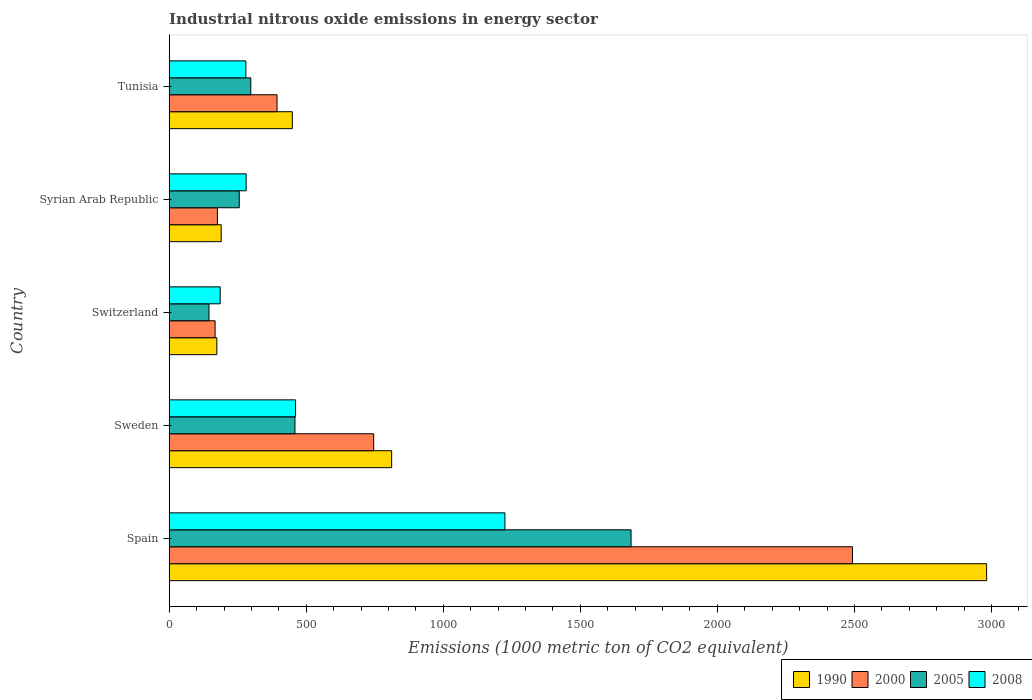How many different coloured bars are there?
Your answer should be compact. 4. Are the number of bars per tick equal to the number of legend labels?
Provide a succinct answer. Yes. Are the number of bars on each tick of the Y-axis equal?
Your answer should be very brief. Yes. How many bars are there on the 1st tick from the top?
Keep it short and to the point. 4. How many bars are there on the 2nd tick from the bottom?
Your answer should be very brief. 4. What is the label of the 2nd group of bars from the top?
Ensure brevity in your answer.  Syrian Arab Republic. In how many cases, is the number of bars for a given country not equal to the number of legend labels?
Offer a terse response. 0. What is the amount of industrial nitrous oxide emitted in 2005 in Syrian Arab Republic?
Your answer should be very brief. 255.6. Across all countries, what is the maximum amount of industrial nitrous oxide emitted in 2008?
Your response must be concise. 1224.9. Across all countries, what is the minimum amount of industrial nitrous oxide emitted in 2000?
Offer a terse response. 167.4. In which country was the amount of industrial nitrous oxide emitted in 1990 minimum?
Ensure brevity in your answer.  Switzerland. What is the total amount of industrial nitrous oxide emitted in 2008 in the graph?
Provide a succinct answer. 2432.5. What is the difference between the amount of industrial nitrous oxide emitted in 2008 in Syrian Arab Republic and that in Tunisia?
Provide a succinct answer. 0.9. What is the difference between the amount of industrial nitrous oxide emitted in 2008 in Syrian Arab Republic and the amount of industrial nitrous oxide emitted in 2000 in Spain?
Offer a terse response. -2212.3. What is the average amount of industrial nitrous oxide emitted in 2005 per country?
Offer a very short reply. 568.46. What is the difference between the amount of industrial nitrous oxide emitted in 1990 and amount of industrial nitrous oxide emitted in 2000 in Sweden?
Your answer should be very brief. 65.5. In how many countries, is the amount of industrial nitrous oxide emitted in 2005 greater than 2500 1000 metric ton?
Your answer should be very brief. 0. What is the ratio of the amount of industrial nitrous oxide emitted in 2005 in Switzerland to that in Tunisia?
Provide a short and direct response. 0.49. Is the difference between the amount of industrial nitrous oxide emitted in 1990 in Switzerland and Tunisia greater than the difference between the amount of industrial nitrous oxide emitted in 2000 in Switzerland and Tunisia?
Make the answer very short. No. What is the difference between the highest and the second highest amount of industrial nitrous oxide emitted in 2005?
Your response must be concise. 1226.3. What is the difference between the highest and the lowest amount of industrial nitrous oxide emitted in 2008?
Offer a terse response. 1038.9. Is it the case that in every country, the sum of the amount of industrial nitrous oxide emitted in 2000 and amount of industrial nitrous oxide emitted in 2008 is greater than the sum of amount of industrial nitrous oxide emitted in 2005 and amount of industrial nitrous oxide emitted in 1990?
Make the answer very short. No. What does the 4th bar from the top in Syrian Arab Republic represents?
Ensure brevity in your answer.  1990. What does the 2nd bar from the bottom in Tunisia represents?
Your response must be concise. 2000. Is it the case that in every country, the sum of the amount of industrial nitrous oxide emitted in 2008 and amount of industrial nitrous oxide emitted in 2000 is greater than the amount of industrial nitrous oxide emitted in 2005?
Make the answer very short. Yes. How many bars are there?
Your answer should be compact. 20. How many countries are there in the graph?
Your response must be concise. 5. What is the difference between two consecutive major ticks on the X-axis?
Your answer should be very brief. 500. Does the graph contain any zero values?
Provide a short and direct response. No. Where does the legend appear in the graph?
Provide a short and direct response. Bottom right. How many legend labels are there?
Make the answer very short. 4. What is the title of the graph?
Your response must be concise. Industrial nitrous oxide emissions in energy sector. Does "1971" appear as one of the legend labels in the graph?
Offer a very short reply. No. What is the label or title of the X-axis?
Your response must be concise. Emissions (1000 metric ton of CO2 equivalent). What is the Emissions (1000 metric ton of CO2 equivalent) in 1990 in Spain?
Offer a terse response. 2982.4. What is the Emissions (1000 metric ton of CO2 equivalent) of 2000 in Spain?
Provide a short and direct response. 2493. What is the Emissions (1000 metric ton of CO2 equivalent) in 2005 in Spain?
Keep it short and to the point. 1685.1. What is the Emissions (1000 metric ton of CO2 equivalent) in 2008 in Spain?
Keep it short and to the point. 1224.9. What is the Emissions (1000 metric ton of CO2 equivalent) of 1990 in Sweden?
Offer a very short reply. 811.6. What is the Emissions (1000 metric ton of CO2 equivalent) of 2000 in Sweden?
Give a very brief answer. 746.1. What is the Emissions (1000 metric ton of CO2 equivalent) in 2005 in Sweden?
Make the answer very short. 458.8. What is the Emissions (1000 metric ton of CO2 equivalent) in 2008 in Sweden?
Offer a very short reply. 461.1. What is the Emissions (1000 metric ton of CO2 equivalent) in 1990 in Switzerland?
Make the answer very short. 173.8. What is the Emissions (1000 metric ton of CO2 equivalent) in 2000 in Switzerland?
Offer a terse response. 167.4. What is the Emissions (1000 metric ton of CO2 equivalent) of 2005 in Switzerland?
Offer a very short reply. 145.1. What is the Emissions (1000 metric ton of CO2 equivalent) of 2008 in Switzerland?
Provide a short and direct response. 186. What is the Emissions (1000 metric ton of CO2 equivalent) of 1990 in Syrian Arab Republic?
Your answer should be very brief. 189.7. What is the Emissions (1000 metric ton of CO2 equivalent) in 2000 in Syrian Arab Republic?
Offer a terse response. 175.8. What is the Emissions (1000 metric ton of CO2 equivalent) in 2005 in Syrian Arab Republic?
Provide a succinct answer. 255.6. What is the Emissions (1000 metric ton of CO2 equivalent) of 2008 in Syrian Arab Republic?
Your answer should be compact. 280.7. What is the Emissions (1000 metric ton of CO2 equivalent) of 1990 in Tunisia?
Offer a very short reply. 449.2. What is the Emissions (1000 metric ton of CO2 equivalent) of 2000 in Tunisia?
Offer a very short reply. 393.4. What is the Emissions (1000 metric ton of CO2 equivalent) in 2005 in Tunisia?
Ensure brevity in your answer.  297.7. What is the Emissions (1000 metric ton of CO2 equivalent) in 2008 in Tunisia?
Make the answer very short. 279.8. Across all countries, what is the maximum Emissions (1000 metric ton of CO2 equivalent) in 1990?
Your answer should be compact. 2982.4. Across all countries, what is the maximum Emissions (1000 metric ton of CO2 equivalent) in 2000?
Ensure brevity in your answer.  2493. Across all countries, what is the maximum Emissions (1000 metric ton of CO2 equivalent) of 2005?
Your response must be concise. 1685.1. Across all countries, what is the maximum Emissions (1000 metric ton of CO2 equivalent) of 2008?
Provide a short and direct response. 1224.9. Across all countries, what is the minimum Emissions (1000 metric ton of CO2 equivalent) in 1990?
Provide a succinct answer. 173.8. Across all countries, what is the minimum Emissions (1000 metric ton of CO2 equivalent) in 2000?
Your answer should be very brief. 167.4. Across all countries, what is the minimum Emissions (1000 metric ton of CO2 equivalent) in 2005?
Provide a short and direct response. 145.1. Across all countries, what is the minimum Emissions (1000 metric ton of CO2 equivalent) of 2008?
Ensure brevity in your answer.  186. What is the total Emissions (1000 metric ton of CO2 equivalent) of 1990 in the graph?
Your answer should be compact. 4606.7. What is the total Emissions (1000 metric ton of CO2 equivalent) in 2000 in the graph?
Provide a short and direct response. 3975.7. What is the total Emissions (1000 metric ton of CO2 equivalent) of 2005 in the graph?
Offer a terse response. 2842.3. What is the total Emissions (1000 metric ton of CO2 equivalent) in 2008 in the graph?
Offer a very short reply. 2432.5. What is the difference between the Emissions (1000 metric ton of CO2 equivalent) of 1990 in Spain and that in Sweden?
Provide a short and direct response. 2170.8. What is the difference between the Emissions (1000 metric ton of CO2 equivalent) of 2000 in Spain and that in Sweden?
Make the answer very short. 1746.9. What is the difference between the Emissions (1000 metric ton of CO2 equivalent) in 2005 in Spain and that in Sweden?
Your answer should be compact. 1226.3. What is the difference between the Emissions (1000 metric ton of CO2 equivalent) in 2008 in Spain and that in Sweden?
Ensure brevity in your answer.  763.8. What is the difference between the Emissions (1000 metric ton of CO2 equivalent) of 1990 in Spain and that in Switzerland?
Your answer should be very brief. 2808.6. What is the difference between the Emissions (1000 metric ton of CO2 equivalent) of 2000 in Spain and that in Switzerland?
Offer a terse response. 2325.6. What is the difference between the Emissions (1000 metric ton of CO2 equivalent) of 2005 in Spain and that in Switzerland?
Provide a short and direct response. 1540. What is the difference between the Emissions (1000 metric ton of CO2 equivalent) in 2008 in Spain and that in Switzerland?
Your response must be concise. 1038.9. What is the difference between the Emissions (1000 metric ton of CO2 equivalent) of 1990 in Spain and that in Syrian Arab Republic?
Provide a succinct answer. 2792.7. What is the difference between the Emissions (1000 metric ton of CO2 equivalent) in 2000 in Spain and that in Syrian Arab Republic?
Make the answer very short. 2317.2. What is the difference between the Emissions (1000 metric ton of CO2 equivalent) in 2005 in Spain and that in Syrian Arab Republic?
Keep it short and to the point. 1429.5. What is the difference between the Emissions (1000 metric ton of CO2 equivalent) in 2008 in Spain and that in Syrian Arab Republic?
Your response must be concise. 944.2. What is the difference between the Emissions (1000 metric ton of CO2 equivalent) in 1990 in Spain and that in Tunisia?
Your answer should be compact. 2533.2. What is the difference between the Emissions (1000 metric ton of CO2 equivalent) in 2000 in Spain and that in Tunisia?
Provide a succinct answer. 2099.6. What is the difference between the Emissions (1000 metric ton of CO2 equivalent) of 2005 in Spain and that in Tunisia?
Keep it short and to the point. 1387.4. What is the difference between the Emissions (1000 metric ton of CO2 equivalent) in 2008 in Spain and that in Tunisia?
Your answer should be compact. 945.1. What is the difference between the Emissions (1000 metric ton of CO2 equivalent) in 1990 in Sweden and that in Switzerland?
Ensure brevity in your answer.  637.8. What is the difference between the Emissions (1000 metric ton of CO2 equivalent) in 2000 in Sweden and that in Switzerland?
Ensure brevity in your answer.  578.7. What is the difference between the Emissions (1000 metric ton of CO2 equivalent) of 2005 in Sweden and that in Switzerland?
Offer a very short reply. 313.7. What is the difference between the Emissions (1000 metric ton of CO2 equivalent) in 2008 in Sweden and that in Switzerland?
Provide a short and direct response. 275.1. What is the difference between the Emissions (1000 metric ton of CO2 equivalent) in 1990 in Sweden and that in Syrian Arab Republic?
Provide a succinct answer. 621.9. What is the difference between the Emissions (1000 metric ton of CO2 equivalent) in 2000 in Sweden and that in Syrian Arab Republic?
Ensure brevity in your answer.  570.3. What is the difference between the Emissions (1000 metric ton of CO2 equivalent) of 2005 in Sweden and that in Syrian Arab Republic?
Provide a short and direct response. 203.2. What is the difference between the Emissions (1000 metric ton of CO2 equivalent) in 2008 in Sweden and that in Syrian Arab Republic?
Offer a terse response. 180.4. What is the difference between the Emissions (1000 metric ton of CO2 equivalent) in 1990 in Sweden and that in Tunisia?
Your answer should be compact. 362.4. What is the difference between the Emissions (1000 metric ton of CO2 equivalent) in 2000 in Sweden and that in Tunisia?
Offer a very short reply. 352.7. What is the difference between the Emissions (1000 metric ton of CO2 equivalent) of 2005 in Sweden and that in Tunisia?
Offer a very short reply. 161.1. What is the difference between the Emissions (1000 metric ton of CO2 equivalent) of 2008 in Sweden and that in Tunisia?
Your answer should be very brief. 181.3. What is the difference between the Emissions (1000 metric ton of CO2 equivalent) in 1990 in Switzerland and that in Syrian Arab Republic?
Your response must be concise. -15.9. What is the difference between the Emissions (1000 metric ton of CO2 equivalent) in 2005 in Switzerland and that in Syrian Arab Republic?
Offer a terse response. -110.5. What is the difference between the Emissions (1000 metric ton of CO2 equivalent) in 2008 in Switzerland and that in Syrian Arab Republic?
Keep it short and to the point. -94.7. What is the difference between the Emissions (1000 metric ton of CO2 equivalent) in 1990 in Switzerland and that in Tunisia?
Your response must be concise. -275.4. What is the difference between the Emissions (1000 metric ton of CO2 equivalent) of 2000 in Switzerland and that in Tunisia?
Ensure brevity in your answer.  -226. What is the difference between the Emissions (1000 metric ton of CO2 equivalent) of 2005 in Switzerland and that in Tunisia?
Ensure brevity in your answer.  -152.6. What is the difference between the Emissions (1000 metric ton of CO2 equivalent) of 2008 in Switzerland and that in Tunisia?
Ensure brevity in your answer.  -93.8. What is the difference between the Emissions (1000 metric ton of CO2 equivalent) in 1990 in Syrian Arab Republic and that in Tunisia?
Provide a succinct answer. -259.5. What is the difference between the Emissions (1000 metric ton of CO2 equivalent) of 2000 in Syrian Arab Republic and that in Tunisia?
Provide a succinct answer. -217.6. What is the difference between the Emissions (1000 metric ton of CO2 equivalent) in 2005 in Syrian Arab Republic and that in Tunisia?
Give a very brief answer. -42.1. What is the difference between the Emissions (1000 metric ton of CO2 equivalent) in 2008 in Syrian Arab Republic and that in Tunisia?
Your answer should be compact. 0.9. What is the difference between the Emissions (1000 metric ton of CO2 equivalent) in 1990 in Spain and the Emissions (1000 metric ton of CO2 equivalent) in 2000 in Sweden?
Ensure brevity in your answer.  2236.3. What is the difference between the Emissions (1000 metric ton of CO2 equivalent) in 1990 in Spain and the Emissions (1000 metric ton of CO2 equivalent) in 2005 in Sweden?
Make the answer very short. 2523.6. What is the difference between the Emissions (1000 metric ton of CO2 equivalent) in 1990 in Spain and the Emissions (1000 metric ton of CO2 equivalent) in 2008 in Sweden?
Keep it short and to the point. 2521.3. What is the difference between the Emissions (1000 metric ton of CO2 equivalent) of 2000 in Spain and the Emissions (1000 metric ton of CO2 equivalent) of 2005 in Sweden?
Provide a short and direct response. 2034.2. What is the difference between the Emissions (1000 metric ton of CO2 equivalent) of 2000 in Spain and the Emissions (1000 metric ton of CO2 equivalent) of 2008 in Sweden?
Provide a short and direct response. 2031.9. What is the difference between the Emissions (1000 metric ton of CO2 equivalent) of 2005 in Spain and the Emissions (1000 metric ton of CO2 equivalent) of 2008 in Sweden?
Offer a very short reply. 1224. What is the difference between the Emissions (1000 metric ton of CO2 equivalent) of 1990 in Spain and the Emissions (1000 metric ton of CO2 equivalent) of 2000 in Switzerland?
Your answer should be compact. 2815. What is the difference between the Emissions (1000 metric ton of CO2 equivalent) of 1990 in Spain and the Emissions (1000 metric ton of CO2 equivalent) of 2005 in Switzerland?
Make the answer very short. 2837.3. What is the difference between the Emissions (1000 metric ton of CO2 equivalent) of 1990 in Spain and the Emissions (1000 metric ton of CO2 equivalent) of 2008 in Switzerland?
Your answer should be compact. 2796.4. What is the difference between the Emissions (1000 metric ton of CO2 equivalent) of 2000 in Spain and the Emissions (1000 metric ton of CO2 equivalent) of 2005 in Switzerland?
Provide a short and direct response. 2347.9. What is the difference between the Emissions (1000 metric ton of CO2 equivalent) of 2000 in Spain and the Emissions (1000 metric ton of CO2 equivalent) of 2008 in Switzerland?
Your answer should be very brief. 2307. What is the difference between the Emissions (1000 metric ton of CO2 equivalent) in 2005 in Spain and the Emissions (1000 metric ton of CO2 equivalent) in 2008 in Switzerland?
Your answer should be very brief. 1499.1. What is the difference between the Emissions (1000 metric ton of CO2 equivalent) of 1990 in Spain and the Emissions (1000 metric ton of CO2 equivalent) of 2000 in Syrian Arab Republic?
Your answer should be compact. 2806.6. What is the difference between the Emissions (1000 metric ton of CO2 equivalent) of 1990 in Spain and the Emissions (1000 metric ton of CO2 equivalent) of 2005 in Syrian Arab Republic?
Provide a succinct answer. 2726.8. What is the difference between the Emissions (1000 metric ton of CO2 equivalent) in 1990 in Spain and the Emissions (1000 metric ton of CO2 equivalent) in 2008 in Syrian Arab Republic?
Keep it short and to the point. 2701.7. What is the difference between the Emissions (1000 metric ton of CO2 equivalent) in 2000 in Spain and the Emissions (1000 metric ton of CO2 equivalent) in 2005 in Syrian Arab Republic?
Keep it short and to the point. 2237.4. What is the difference between the Emissions (1000 metric ton of CO2 equivalent) in 2000 in Spain and the Emissions (1000 metric ton of CO2 equivalent) in 2008 in Syrian Arab Republic?
Keep it short and to the point. 2212.3. What is the difference between the Emissions (1000 metric ton of CO2 equivalent) of 2005 in Spain and the Emissions (1000 metric ton of CO2 equivalent) of 2008 in Syrian Arab Republic?
Provide a succinct answer. 1404.4. What is the difference between the Emissions (1000 metric ton of CO2 equivalent) in 1990 in Spain and the Emissions (1000 metric ton of CO2 equivalent) in 2000 in Tunisia?
Keep it short and to the point. 2589. What is the difference between the Emissions (1000 metric ton of CO2 equivalent) of 1990 in Spain and the Emissions (1000 metric ton of CO2 equivalent) of 2005 in Tunisia?
Provide a short and direct response. 2684.7. What is the difference between the Emissions (1000 metric ton of CO2 equivalent) in 1990 in Spain and the Emissions (1000 metric ton of CO2 equivalent) in 2008 in Tunisia?
Your response must be concise. 2702.6. What is the difference between the Emissions (1000 metric ton of CO2 equivalent) in 2000 in Spain and the Emissions (1000 metric ton of CO2 equivalent) in 2005 in Tunisia?
Keep it short and to the point. 2195.3. What is the difference between the Emissions (1000 metric ton of CO2 equivalent) of 2000 in Spain and the Emissions (1000 metric ton of CO2 equivalent) of 2008 in Tunisia?
Your response must be concise. 2213.2. What is the difference between the Emissions (1000 metric ton of CO2 equivalent) in 2005 in Spain and the Emissions (1000 metric ton of CO2 equivalent) in 2008 in Tunisia?
Offer a terse response. 1405.3. What is the difference between the Emissions (1000 metric ton of CO2 equivalent) of 1990 in Sweden and the Emissions (1000 metric ton of CO2 equivalent) of 2000 in Switzerland?
Your answer should be very brief. 644.2. What is the difference between the Emissions (1000 metric ton of CO2 equivalent) of 1990 in Sweden and the Emissions (1000 metric ton of CO2 equivalent) of 2005 in Switzerland?
Your response must be concise. 666.5. What is the difference between the Emissions (1000 metric ton of CO2 equivalent) in 1990 in Sweden and the Emissions (1000 metric ton of CO2 equivalent) in 2008 in Switzerland?
Your answer should be compact. 625.6. What is the difference between the Emissions (1000 metric ton of CO2 equivalent) in 2000 in Sweden and the Emissions (1000 metric ton of CO2 equivalent) in 2005 in Switzerland?
Keep it short and to the point. 601. What is the difference between the Emissions (1000 metric ton of CO2 equivalent) of 2000 in Sweden and the Emissions (1000 metric ton of CO2 equivalent) of 2008 in Switzerland?
Ensure brevity in your answer.  560.1. What is the difference between the Emissions (1000 metric ton of CO2 equivalent) in 2005 in Sweden and the Emissions (1000 metric ton of CO2 equivalent) in 2008 in Switzerland?
Provide a short and direct response. 272.8. What is the difference between the Emissions (1000 metric ton of CO2 equivalent) in 1990 in Sweden and the Emissions (1000 metric ton of CO2 equivalent) in 2000 in Syrian Arab Republic?
Provide a succinct answer. 635.8. What is the difference between the Emissions (1000 metric ton of CO2 equivalent) of 1990 in Sweden and the Emissions (1000 metric ton of CO2 equivalent) of 2005 in Syrian Arab Republic?
Your answer should be very brief. 556. What is the difference between the Emissions (1000 metric ton of CO2 equivalent) of 1990 in Sweden and the Emissions (1000 metric ton of CO2 equivalent) of 2008 in Syrian Arab Republic?
Offer a very short reply. 530.9. What is the difference between the Emissions (1000 metric ton of CO2 equivalent) in 2000 in Sweden and the Emissions (1000 metric ton of CO2 equivalent) in 2005 in Syrian Arab Republic?
Your answer should be very brief. 490.5. What is the difference between the Emissions (1000 metric ton of CO2 equivalent) of 2000 in Sweden and the Emissions (1000 metric ton of CO2 equivalent) of 2008 in Syrian Arab Republic?
Give a very brief answer. 465.4. What is the difference between the Emissions (1000 metric ton of CO2 equivalent) of 2005 in Sweden and the Emissions (1000 metric ton of CO2 equivalent) of 2008 in Syrian Arab Republic?
Offer a very short reply. 178.1. What is the difference between the Emissions (1000 metric ton of CO2 equivalent) of 1990 in Sweden and the Emissions (1000 metric ton of CO2 equivalent) of 2000 in Tunisia?
Give a very brief answer. 418.2. What is the difference between the Emissions (1000 metric ton of CO2 equivalent) in 1990 in Sweden and the Emissions (1000 metric ton of CO2 equivalent) in 2005 in Tunisia?
Offer a very short reply. 513.9. What is the difference between the Emissions (1000 metric ton of CO2 equivalent) in 1990 in Sweden and the Emissions (1000 metric ton of CO2 equivalent) in 2008 in Tunisia?
Offer a very short reply. 531.8. What is the difference between the Emissions (1000 metric ton of CO2 equivalent) in 2000 in Sweden and the Emissions (1000 metric ton of CO2 equivalent) in 2005 in Tunisia?
Offer a terse response. 448.4. What is the difference between the Emissions (1000 metric ton of CO2 equivalent) of 2000 in Sweden and the Emissions (1000 metric ton of CO2 equivalent) of 2008 in Tunisia?
Your answer should be compact. 466.3. What is the difference between the Emissions (1000 metric ton of CO2 equivalent) in 2005 in Sweden and the Emissions (1000 metric ton of CO2 equivalent) in 2008 in Tunisia?
Keep it short and to the point. 179. What is the difference between the Emissions (1000 metric ton of CO2 equivalent) of 1990 in Switzerland and the Emissions (1000 metric ton of CO2 equivalent) of 2005 in Syrian Arab Republic?
Your answer should be compact. -81.8. What is the difference between the Emissions (1000 metric ton of CO2 equivalent) of 1990 in Switzerland and the Emissions (1000 metric ton of CO2 equivalent) of 2008 in Syrian Arab Republic?
Offer a terse response. -106.9. What is the difference between the Emissions (1000 metric ton of CO2 equivalent) of 2000 in Switzerland and the Emissions (1000 metric ton of CO2 equivalent) of 2005 in Syrian Arab Republic?
Keep it short and to the point. -88.2. What is the difference between the Emissions (1000 metric ton of CO2 equivalent) in 2000 in Switzerland and the Emissions (1000 metric ton of CO2 equivalent) in 2008 in Syrian Arab Republic?
Provide a short and direct response. -113.3. What is the difference between the Emissions (1000 metric ton of CO2 equivalent) of 2005 in Switzerland and the Emissions (1000 metric ton of CO2 equivalent) of 2008 in Syrian Arab Republic?
Give a very brief answer. -135.6. What is the difference between the Emissions (1000 metric ton of CO2 equivalent) of 1990 in Switzerland and the Emissions (1000 metric ton of CO2 equivalent) of 2000 in Tunisia?
Your answer should be very brief. -219.6. What is the difference between the Emissions (1000 metric ton of CO2 equivalent) in 1990 in Switzerland and the Emissions (1000 metric ton of CO2 equivalent) in 2005 in Tunisia?
Keep it short and to the point. -123.9. What is the difference between the Emissions (1000 metric ton of CO2 equivalent) in 1990 in Switzerland and the Emissions (1000 metric ton of CO2 equivalent) in 2008 in Tunisia?
Give a very brief answer. -106. What is the difference between the Emissions (1000 metric ton of CO2 equivalent) in 2000 in Switzerland and the Emissions (1000 metric ton of CO2 equivalent) in 2005 in Tunisia?
Offer a very short reply. -130.3. What is the difference between the Emissions (1000 metric ton of CO2 equivalent) in 2000 in Switzerland and the Emissions (1000 metric ton of CO2 equivalent) in 2008 in Tunisia?
Ensure brevity in your answer.  -112.4. What is the difference between the Emissions (1000 metric ton of CO2 equivalent) in 2005 in Switzerland and the Emissions (1000 metric ton of CO2 equivalent) in 2008 in Tunisia?
Offer a terse response. -134.7. What is the difference between the Emissions (1000 metric ton of CO2 equivalent) in 1990 in Syrian Arab Republic and the Emissions (1000 metric ton of CO2 equivalent) in 2000 in Tunisia?
Offer a very short reply. -203.7. What is the difference between the Emissions (1000 metric ton of CO2 equivalent) of 1990 in Syrian Arab Republic and the Emissions (1000 metric ton of CO2 equivalent) of 2005 in Tunisia?
Keep it short and to the point. -108. What is the difference between the Emissions (1000 metric ton of CO2 equivalent) of 1990 in Syrian Arab Republic and the Emissions (1000 metric ton of CO2 equivalent) of 2008 in Tunisia?
Your answer should be very brief. -90.1. What is the difference between the Emissions (1000 metric ton of CO2 equivalent) in 2000 in Syrian Arab Republic and the Emissions (1000 metric ton of CO2 equivalent) in 2005 in Tunisia?
Keep it short and to the point. -121.9. What is the difference between the Emissions (1000 metric ton of CO2 equivalent) of 2000 in Syrian Arab Republic and the Emissions (1000 metric ton of CO2 equivalent) of 2008 in Tunisia?
Give a very brief answer. -104. What is the difference between the Emissions (1000 metric ton of CO2 equivalent) in 2005 in Syrian Arab Republic and the Emissions (1000 metric ton of CO2 equivalent) in 2008 in Tunisia?
Your response must be concise. -24.2. What is the average Emissions (1000 metric ton of CO2 equivalent) of 1990 per country?
Your answer should be compact. 921.34. What is the average Emissions (1000 metric ton of CO2 equivalent) of 2000 per country?
Your response must be concise. 795.14. What is the average Emissions (1000 metric ton of CO2 equivalent) in 2005 per country?
Your answer should be very brief. 568.46. What is the average Emissions (1000 metric ton of CO2 equivalent) in 2008 per country?
Give a very brief answer. 486.5. What is the difference between the Emissions (1000 metric ton of CO2 equivalent) of 1990 and Emissions (1000 metric ton of CO2 equivalent) of 2000 in Spain?
Ensure brevity in your answer.  489.4. What is the difference between the Emissions (1000 metric ton of CO2 equivalent) in 1990 and Emissions (1000 metric ton of CO2 equivalent) in 2005 in Spain?
Provide a short and direct response. 1297.3. What is the difference between the Emissions (1000 metric ton of CO2 equivalent) of 1990 and Emissions (1000 metric ton of CO2 equivalent) of 2008 in Spain?
Make the answer very short. 1757.5. What is the difference between the Emissions (1000 metric ton of CO2 equivalent) in 2000 and Emissions (1000 metric ton of CO2 equivalent) in 2005 in Spain?
Your answer should be compact. 807.9. What is the difference between the Emissions (1000 metric ton of CO2 equivalent) in 2000 and Emissions (1000 metric ton of CO2 equivalent) in 2008 in Spain?
Your answer should be very brief. 1268.1. What is the difference between the Emissions (1000 metric ton of CO2 equivalent) in 2005 and Emissions (1000 metric ton of CO2 equivalent) in 2008 in Spain?
Your answer should be very brief. 460.2. What is the difference between the Emissions (1000 metric ton of CO2 equivalent) of 1990 and Emissions (1000 metric ton of CO2 equivalent) of 2000 in Sweden?
Provide a succinct answer. 65.5. What is the difference between the Emissions (1000 metric ton of CO2 equivalent) in 1990 and Emissions (1000 metric ton of CO2 equivalent) in 2005 in Sweden?
Keep it short and to the point. 352.8. What is the difference between the Emissions (1000 metric ton of CO2 equivalent) of 1990 and Emissions (1000 metric ton of CO2 equivalent) of 2008 in Sweden?
Ensure brevity in your answer.  350.5. What is the difference between the Emissions (1000 metric ton of CO2 equivalent) in 2000 and Emissions (1000 metric ton of CO2 equivalent) in 2005 in Sweden?
Your answer should be very brief. 287.3. What is the difference between the Emissions (1000 metric ton of CO2 equivalent) of 2000 and Emissions (1000 metric ton of CO2 equivalent) of 2008 in Sweden?
Give a very brief answer. 285. What is the difference between the Emissions (1000 metric ton of CO2 equivalent) in 2005 and Emissions (1000 metric ton of CO2 equivalent) in 2008 in Sweden?
Your response must be concise. -2.3. What is the difference between the Emissions (1000 metric ton of CO2 equivalent) of 1990 and Emissions (1000 metric ton of CO2 equivalent) of 2005 in Switzerland?
Your answer should be very brief. 28.7. What is the difference between the Emissions (1000 metric ton of CO2 equivalent) in 1990 and Emissions (1000 metric ton of CO2 equivalent) in 2008 in Switzerland?
Provide a succinct answer. -12.2. What is the difference between the Emissions (1000 metric ton of CO2 equivalent) of 2000 and Emissions (1000 metric ton of CO2 equivalent) of 2005 in Switzerland?
Provide a succinct answer. 22.3. What is the difference between the Emissions (1000 metric ton of CO2 equivalent) of 2000 and Emissions (1000 metric ton of CO2 equivalent) of 2008 in Switzerland?
Keep it short and to the point. -18.6. What is the difference between the Emissions (1000 metric ton of CO2 equivalent) in 2005 and Emissions (1000 metric ton of CO2 equivalent) in 2008 in Switzerland?
Provide a short and direct response. -40.9. What is the difference between the Emissions (1000 metric ton of CO2 equivalent) of 1990 and Emissions (1000 metric ton of CO2 equivalent) of 2005 in Syrian Arab Republic?
Keep it short and to the point. -65.9. What is the difference between the Emissions (1000 metric ton of CO2 equivalent) of 1990 and Emissions (1000 metric ton of CO2 equivalent) of 2008 in Syrian Arab Republic?
Provide a short and direct response. -91. What is the difference between the Emissions (1000 metric ton of CO2 equivalent) of 2000 and Emissions (1000 metric ton of CO2 equivalent) of 2005 in Syrian Arab Republic?
Your response must be concise. -79.8. What is the difference between the Emissions (1000 metric ton of CO2 equivalent) of 2000 and Emissions (1000 metric ton of CO2 equivalent) of 2008 in Syrian Arab Republic?
Ensure brevity in your answer.  -104.9. What is the difference between the Emissions (1000 metric ton of CO2 equivalent) of 2005 and Emissions (1000 metric ton of CO2 equivalent) of 2008 in Syrian Arab Republic?
Offer a very short reply. -25.1. What is the difference between the Emissions (1000 metric ton of CO2 equivalent) of 1990 and Emissions (1000 metric ton of CO2 equivalent) of 2000 in Tunisia?
Your answer should be very brief. 55.8. What is the difference between the Emissions (1000 metric ton of CO2 equivalent) of 1990 and Emissions (1000 metric ton of CO2 equivalent) of 2005 in Tunisia?
Offer a very short reply. 151.5. What is the difference between the Emissions (1000 metric ton of CO2 equivalent) in 1990 and Emissions (1000 metric ton of CO2 equivalent) in 2008 in Tunisia?
Your answer should be very brief. 169.4. What is the difference between the Emissions (1000 metric ton of CO2 equivalent) in 2000 and Emissions (1000 metric ton of CO2 equivalent) in 2005 in Tunisia?
Your answer should be compact. 95.7. What is the difference between the Emissions (1000 metric ton of CO2 equivalent) in 2000 and Emissions (1000 metric ton of CO2 equivalent) in 2008 in Tunisia?
Offer a very short reply. 113.6. What is the ratio of the Emissions (1000 metric ton of CO2 equivalent) in 1990 in Spain to that in Sweden?
Keep it short and to the point. 3.67. What is the ratio of the Emissions (1000 metric ton of CO2 equivalent) in 2000 in Spain to that in Sweden?
Offer a very short reply. 3.34. What is the ratio of the Emissions (1000 metric ton of CO2 equivalent) in 2005 in Spain to that in Sweden?
Keep it short and to the point. 3.67. What is the ratio of the Emissions (1000 metric ton of CO2 equivalent) in 2008 in Spain to that in Sweden?
Provide a succinct answer. 2.66. What is the ratio of the Emissions (1000 metric ton of CO2 equivalent) in 1990 in Spain to that in Switzerland?
Offer a very short reply. 17.16. What is the ratio of the Emissions (1000 metric ton of CO2 equivalent) in 2000 in Spain to that in Switzerland?
Your answer should be compact. 14.89. What is the ratio of the Emissions (1000 metric ton of CO2 equivalent) of 2005 in Spain to that in Switzerland?
Keep it short and to the point. 11.61. What is the ratio of the Emissions (1000 metric ton of CO2 equivalent) of 2008 in Spain to that in Switzerland?
Make the answer very short. 6.59. What is the ratio of the Emissions (1000 metric ton of CO2 equivalent) of 1990 in Spain to that in Syrian Arab Republic?
Your answer should be compact. 15.72. What is the ratio of the Emissions (1000 metric ton of CO2 equivalent) in 2000 in Spain to that in Syrian Arab Republic?
Offer a terse response. 14.18. What is the ratio of the Emissions (1000 metric ton of CO2 equivalent) of 2005 in Spain to that in Syrian Arab Republic?
Ensure brevity in your answer.  6.59. What is the ratio of the Emissions (1000 metric ton of CO2 equivalent) of 2008 in Spain to that in Syrian Arab Republic?
Provide a short and direct response. 4.36. What is the ratio of the Emissions (1000 metric ton of CO2 equivalent) in 1990 in Spain to that in Tunisia?
Make the answer very short. 6.64. What is the ratio of the Emissions (1000 metric ton of CO2 equivalent) in 2000 in Spain to that in Tunisia?
Make the answer very short. 6.34. What is the ratio of the Emissions (1000 metric ton of CO2 equivalent) of 2005 in Spain to that in Tunisia?
Offer a very short reply. 5.66. What is the ratio of the Emissions (1000 metric ton of CO2 equivalent) in 2008 in Spain to that in Tunisia?
Make the answer very short. 4.38. What is the ratio of the Emissions (1000 metric ton of CO2 equivalent) of 1990 in Sweden to that in Switzerland?
Provide a short and direct response. 4.67. What is the ratio of the Emissions (1000 metric ton of CO2 equivalent) in 2000 in Sweden to that in Switzerland?
Your answer should be very brief. 4.46. What is the ratio of the Emissions (1000 metric ton of CO2 equivalent) in 2005 in Sweden to that in Switzerland?
Provide a succinct answer. 3.16. What is the ratio of the Emissions (1000 metric ton of CO2 equivalent) of 2008 in Sweden to that in Switzerland?
Your response must be concise. 2.48. What is the ratio of the Emissions (1000 metric ton of CO2 equivalent) in 1990 in Sweden to that in Syrian Arab Republic?
Make the answer very short. 4.28. What is the ratio of the Emissions (1000 metric ton of CO2 equivalent) of 2000 in Sweden to that in Syrian Arab Republic?
Keep it short and to the point. 4.24. What is the ratio of the Emissions (1000 metric ton of CO2 equivalent) of 2005 in Sweden to that in Syrian Arab Republic?
Provide a succinct answer. 1.79. What is the ratio of the Emissions (1000 metric ton of CO2 equivalent) of 2008 in Sweden to that in Syrian Arab Republic?
Your response must be concise. 1.64. What is the ratio of the Emissions (1000 metric ton of CO2 equivalent) of 1990 in Sweden to that in Tunisia?
Provide a short and direct response. 1.81. What is the ratio of the Emissions (1000 metric ton of CO2 equivalent) in 2000 in Sweden to that in Tunisia?
Make the answer very short. 1.9. What is the ratio of the Emissions (1000 metric ton of CO2 equivalent) in 2005 in Sweden to that in Tunisia?
Offer a very short reply. 1.54. What is the ratio of the Emissions (1000 metric ton of CO2 equivalent) in 2008 in Sweden to that in Tunisia?
Ensure brevity in your answer.  1.65. What is the ratio of the Emissions (1000 metric ton of CO2 equivalent) of 1990 in Switzerland to that in Syrian Arab Republic?
Your response must be concise. 0.92. What is the ratio of the Emissions (1000 metric ton of CO2 equivalent) in 2000 in Switzerland to that in Syrian Arab Republic?
Offer a terse response. 0.95. What is the ratio of the Emissions (1000 metric ton of CO2 equivalent) in 2005 in Switzerland to that in Syrian Arab Republic?
Your response must be concise. 0.57. What is the ratio of the Emissions (1000 metric ton of CO2 equivalent) of 2008 in Switzerland to that in Syrian Arab Republic?
Provide a succinct answer. 0.66. What is the ratio of the Emissions (1000 metric ton of CO2 equivalent) of 1990 in Switzerland to that in Tunisia?
Provide a succinct answer. 0.39. What is the ratio of the Emissions (1000 metric ton of CO2 equivalent) of 2000 in Switzerland to that in Tunisia?
Your answer should be compact. 0.43. What is the ratio of the Emissions (1000 metric ton of CO2 equivalent) in 2005 in Switzerland to that in Tunisia?
Give a very brief answer. 0.49. What is the ratio of the Emissions (1000 metric ton of CO2 equivalent) in 2008 in Switzerland to that in Tunisia?
Offer a terse response. 0.66. What is the ratio of the Emissions (1000 metric ton of CO2 equivalent) in 1990 in Syrian Arab Republic to that in Tunisia?
Make the answer very short. 0.42. What is the ratio of the Emissions (1000 metric ton of CO2 equivalent) of 2000 in Syrian Arab Republic to that in Tunisia?
Keep it short and to the point. 0.45. What is the ratio of the Emissions (1000 metric ton of CO2 equivalent) in 2005 in Syrian Arab Republic to that in Tunisia?
Ensure brevity in your answer.  0.86. What is the difference between the highest and the second highest Emissions (1000 metric ton of CO2 equivalent) of 1990?
Ensure brevity in your answer.  2170.8. What is the difference between the highest and the second highest Emissions (1000 metric ton of CO2 equivalent) of 2000?
Give a very brief answer. 1746.9. What is the difference between the highest and the second highest Emissions (1000 metric ton of CO2 equivalent) of 2005?
Offer a terse response. 1226.3. What is the difference between the highest and the second highest Emissions (1000 metric ton of CO2 equivalent) of 2008?
Your answer should be compact. 763.8. What is the difference between the highest and the lowest Emissions (1000 metric ton of CO2 equivalent) of 1990?
Keep it short and to the point. 2808.6. What is the difference between the highest and the lowest Emissions (1000 metric ton of CO2 equivalent) of 2000?
Keep it short and to the point. 2325.6. What is the difference between the highest and the lowest Emissions (1000 metric ton of CO2 equivalent) in 2005?
Make the answer very short. 1540. What is the difference between the highest and the lowest Emissions (1000 metric ton of CO2 equivalent) in 2008?
Provide a succinct answer. 1038.9. 